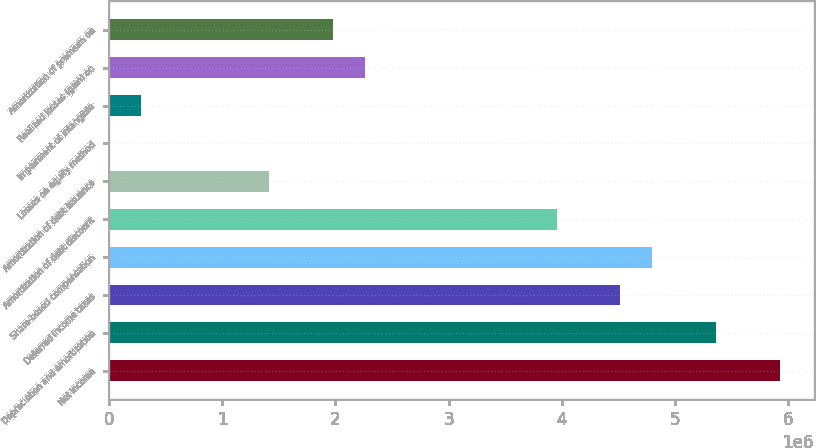Convert chart to OTSL. <chart><loc_0><loc_0><loc_500><loc_500><bar_chart><fcel>Net income<fcel>Depreciation and amortization<fcel>Deferred income taxes<fcel>Share-based compensation<fcel>Amortization of debt discount<fcel>Amortization of debt issuance<fcel>Losses on equity method<fcel>Impairment of intangible<fcel>Realized losses (gain) on<fcel>Amortization of premium on<nl><fcel>5.93051e+06<fcel>5.36573e+06<fcel>4.51856e+06<fcel>4.80095e+06<fcel>3.95379e+06<fcel>1.41229e+06<fcel>345<fcel>282734<fcel>2.25945e+06<fcel>1.97707e+06<nl></chart> 